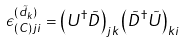Convert formula to latex. <formula><loc_0><loc_0><loc_500><loc_500>\epsilon _ { ( C ) j i } ^ { ( \tilde { d } _ { k } ) } = \left ( U ^ { \dag } \tilde { D } \right ) _ { j k } \left ( \tilde { D } ^ { \dag } \tilde { U } \right ) _ { k i }</formula> 